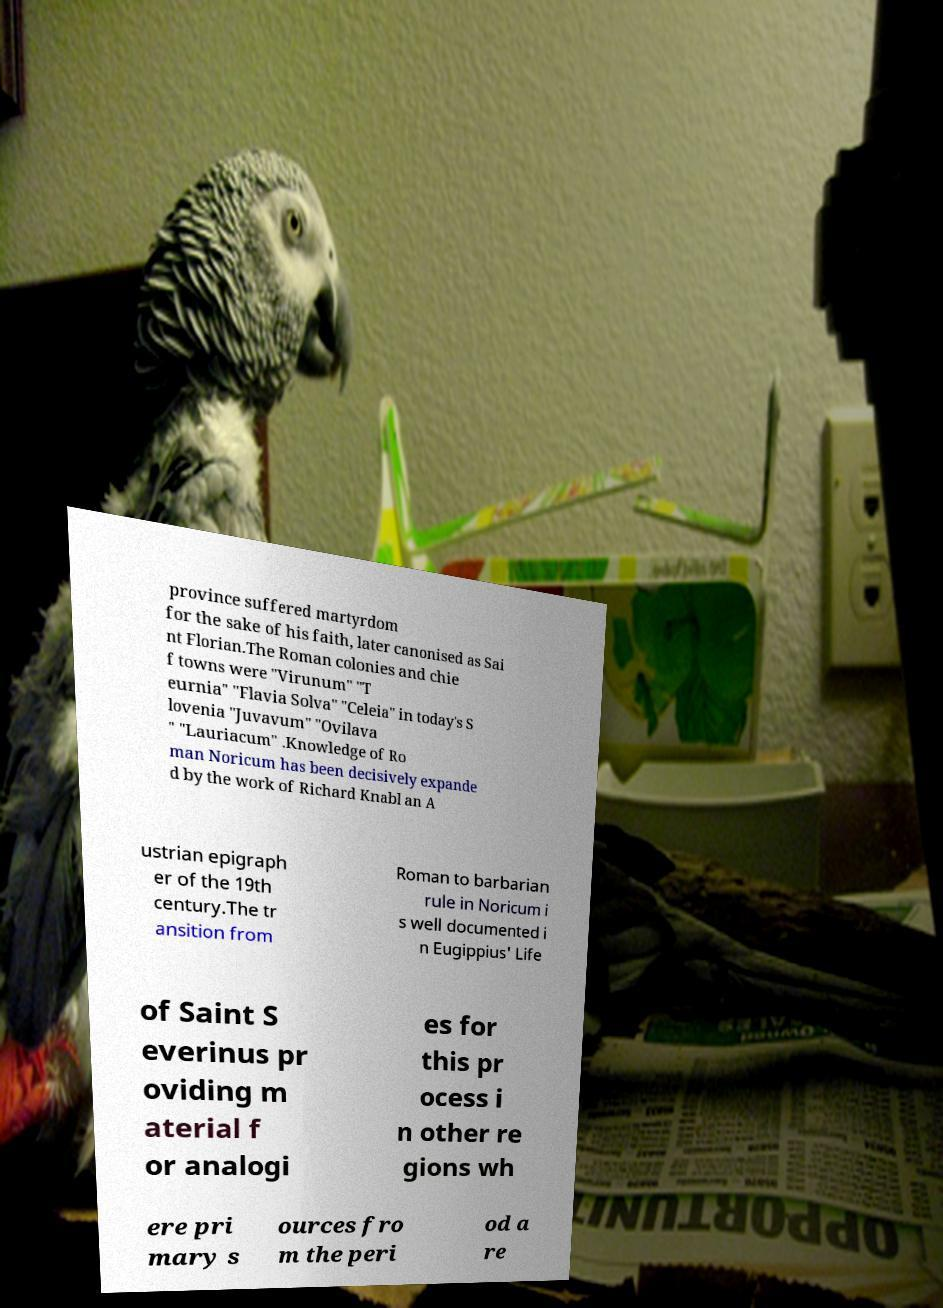Could you assist in decoding the text presented in this image and type it out clearly? province suffered martyrdom for the sake of his faith, later canonised as Sai nt Florian.The Roman colonies and chie f towns were "Virunum" "T eurnia" "Flavia Solva" "Celeia" in today's S lovenia "Juvavum" "Ovilava " "Lauriacum" .Knowledge of Ro man Noricum has been decisively expande d by the work of Richard Knabl an A ustrian epigraph er of the 19th century.The tr ansition from Roman to barbarian rule in Noricum i s well documented i n Eugippius' Life of Saint S everinus pr oviding m aterial f or analogi es for this pr ocess i n other re gions wh ere pri mary s ources fro m the peri od a re 